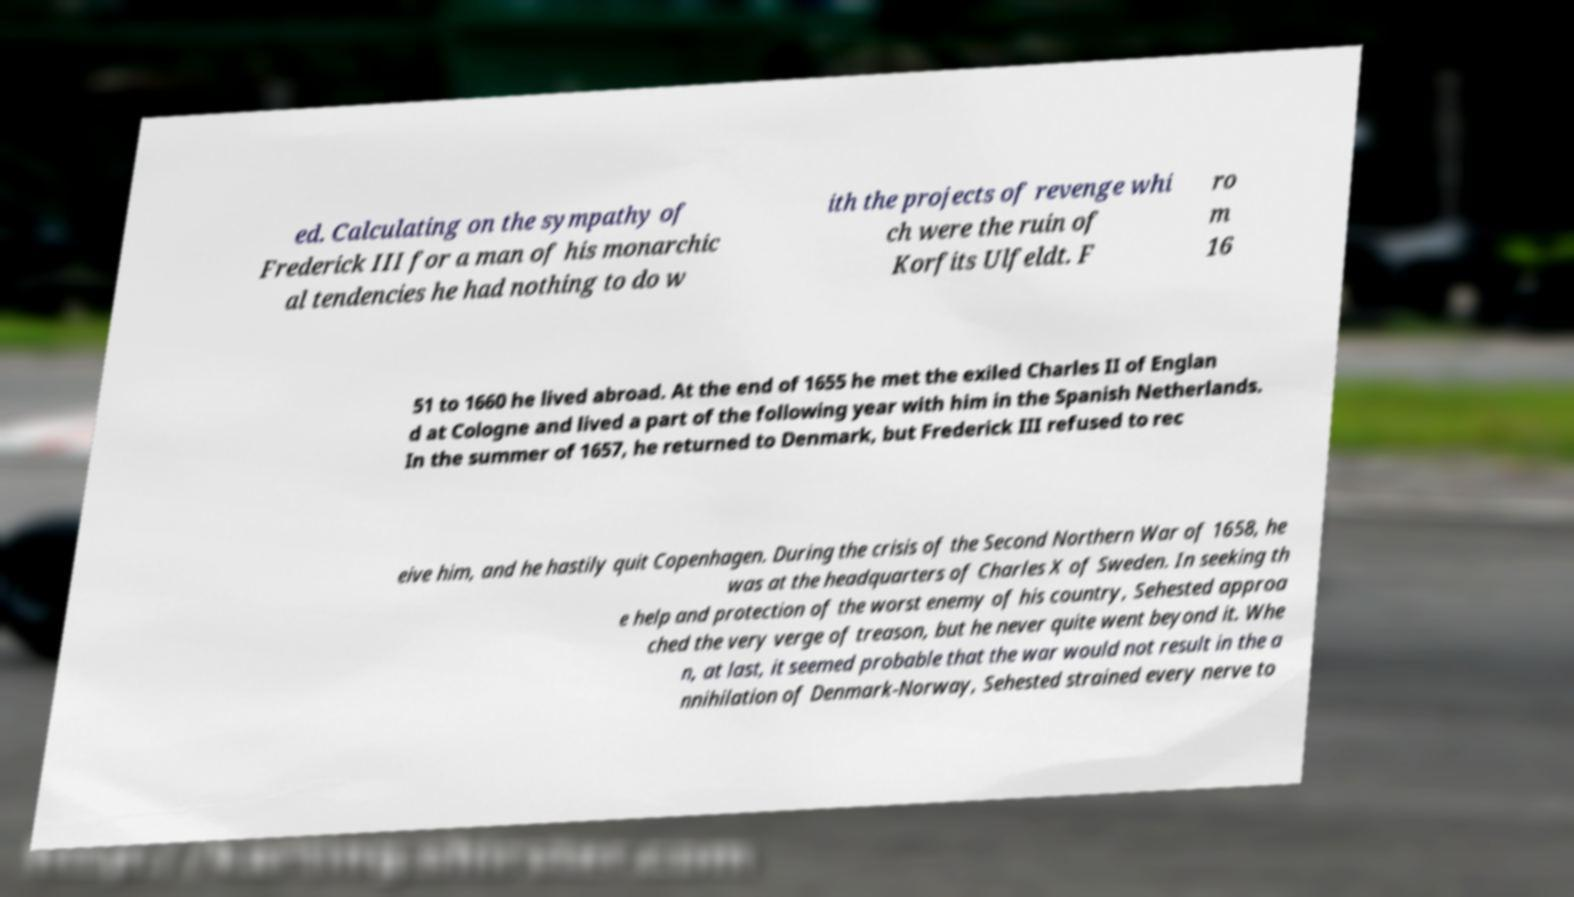What messages or text are displayed in this image? I need them in a readable, typed format. ed. Calculating on the sympathy of Frederick III for a man of his monarchic al tendencies he had nothing to do w ith the projects of revenge whi ch were the ruin of Korfits Ulfeldt. F ro m 16 51 to 1660 he lived abroad. At the end of 1655 he met the exiled Charles II of Englan d at Cologne and lived a part of the following year with him in the Spanish Netherlands. In the summer of 1657, he returned to Denmark, but Frederick III refused to rec eive him, and he hastily quit Copenhagen. During the crisis of the Second Northern War of 1658, he was at the headquarters of Charles X of Sweden. In seeking th e help and protection of the worst enemy of his country, Sehested approa ched the very verge of treason, but he never quite went beyond it. Whe n, at last, it seemed probable that the war would not result in the a nnihilation of Denmark-Norway, Sehested strained every nerve to 